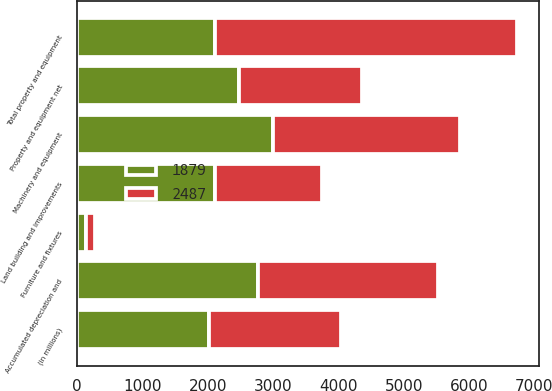Convert chart to OTSL. <chart><loc_0><loc_0><loc_500><loc_500><stacked_bar_chart><ecel><fcel>(in millions)<fcel>Land building and improvements<fcel>Machinery and equipment<fcel>Furniture and fixtures<fcel>Total property and equipment<fcel>Accumulated depreciation and<fcel>Property and equipment net<nl><fcel>1879<fcel>2018<fcel>2115<fcel>3006<fcel>139<fcel>2115<fcel>2773<fcel>2487<nl><fcel>2487<fcel>2017<fcel>1637<fcel>2860<fcel>130<fcel>4627<fcel>2748<fcel>1879<nl></chart> 